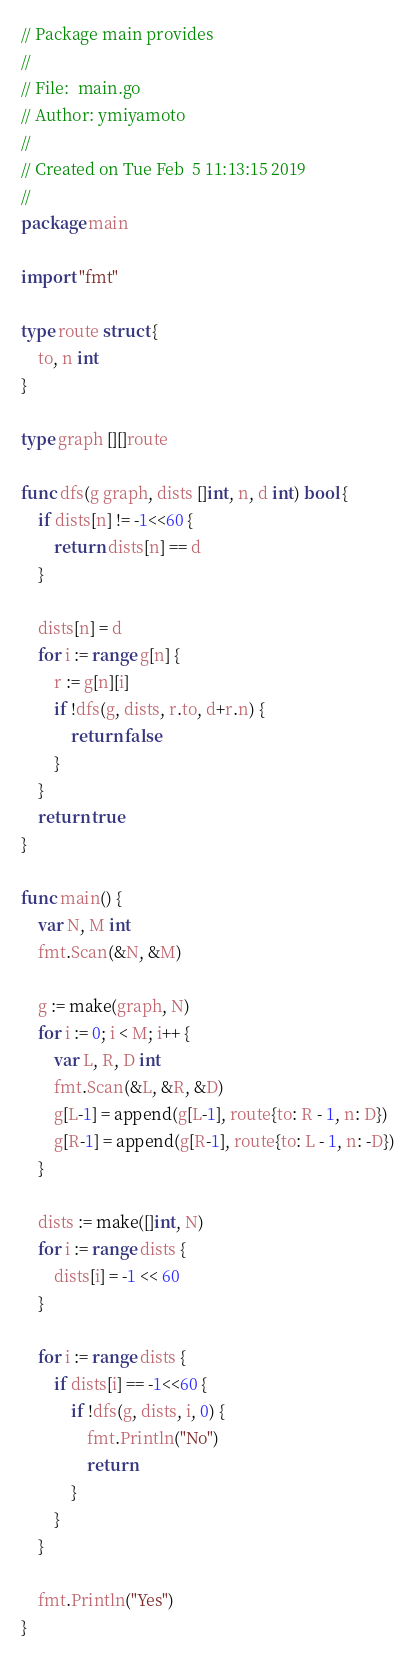<code> <loc_0><loc_0><loc_500><loc_500><_Go_>// Package main provides
//
// File:  main.go
// Author: ymiyamoto
//
// Created on Tue Feb  5 11:13:15 2019
//
package main

import "fmt"

type route struct {
	to, n int
}

type graph [][]route

func dfs(g graph, dists []int, n, d int) bool {
	if dists[n] != -1<<60 {
		return dists[n] == d
	}

	dists[n] = d
	for i := range g[n] {
		r := g[n][i]
		if !dfs(g, dists, r.to, d+r.n) {
			return false
		}
	}
	return true
}

func main() {
	var N, M int
	fmt.Scan(&N, &M)

	g := make(graph, N)
	for i := 0; i < M; i++ {
		var L, R, D int
		fmt.Scan(&L, &R, &D)
		g[L-1] = append(g[L-1], route{to: R - 1, n: D})
		g[R-1] = append(g[R-1], route{to: L - 1, n: -D})
	}

	dists := make([]int, N)
	for i := range dists {
		dists[i] = -1 << 60
	}

	for i := range dists {
		if dists[i] == -1<<60 {
			if !dfs(g, dists, i, 0) {
				fmt.Println("No")
				return
			}
		}
	}

	fmt.Println("Yes")
}
</code> 